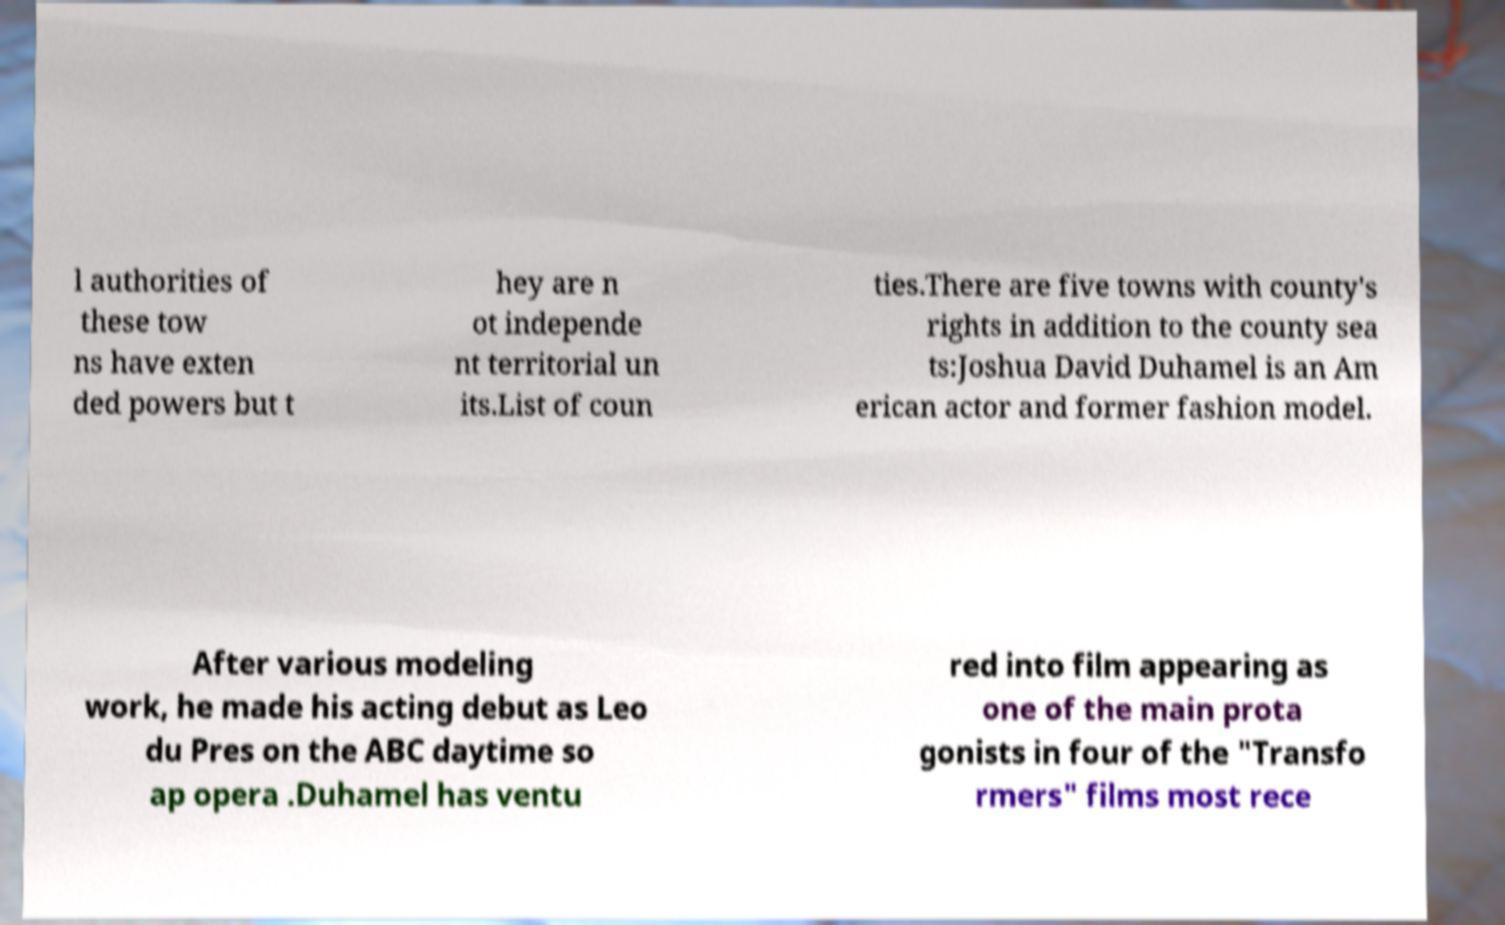Can you read and provide the text displayed in the image?This photo seems to have some interesting text. Can you extract and type it out for me? l authorities of these tow ns have exten ded powers but t hey are n ot independe nt territorial un its.List of coun ties.There are five towns with county's rights in addition to the county sea ts:Joshua David Duhamel is an Am erican actor and former fashion model. After various modeling work, he made his acting debut as Leo du Pres on the ABC daytime so ap opera .Duhamel has ventu red into film appearing as one of the main prota gonists in four of the "Transfo rmers" films most rece 